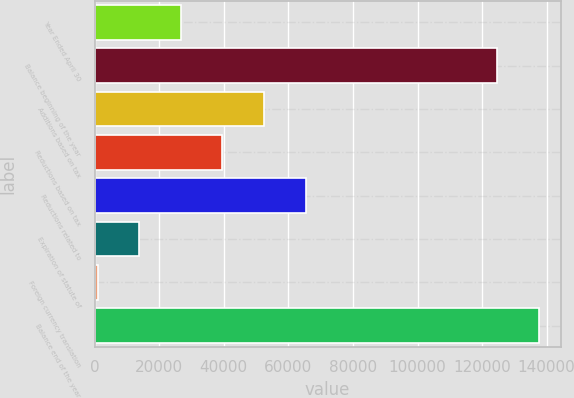Convert chart to OTSL. <chart><loc_0><loc_0><loc_500><loc_500><bar_chart><fcel>Year Ended April 30<fcel>Balance beginning of the year<fcel>Additions based on tax<fcel>Reductions based on tax<fcel>Reductions related to<fcel>Expiration of statute of<fcel>Foreign currency translation<fcel>Balance end of the year<nl><fcel>26692.6<fcel>124605<fcel>52461.2<fcel>39576.9<fcel>65345.5<fcel>13808.3<fcel>924<fcel>137489<nl></chart> 